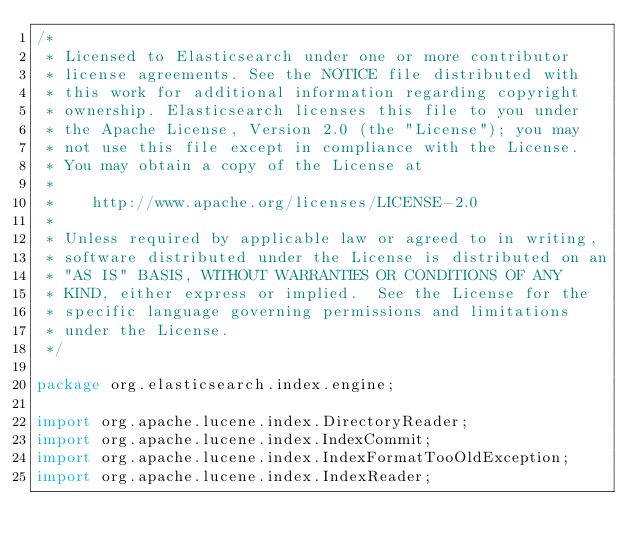<code> <loc_0><loc_0><loc_500><loc_500><_Java_>/*
 * Licensed to Elasticsearch under one or more contributor
 * license agreements. See the NOTICE file distributed with
 * this work for additional information regarding copyright
 * ownership. Elasticsearch licenses this file to you under
 * the Apache License, Version 2.0 (the "License"); you may
 * not use this file except in compliance with the License.
 * You may obtain a copy of the License at
 *
 *    http://www.apache.org/licenses/LICENSE-2.0
 *
 * Unless required by applicable law or agreed to in writing,
 * software distributed under the License is distributed on an
 * "AS IS" BASIS, WITHOUT WARRANTIES OR CONDITIONS OF ANY
 * KIND, either express or implied.  See the License for the
 * specific language governing permissions and limitations
 * under the License.
 */

package org.elasticsearch.index.engine;

import org.apache.lucene.index.DirectoryReader;
import org.apache.lucene.index.IndexCommit;
import org.apache.lucene.index.IndexFormatTooOldException;
import org.apache.lucene.index.IndexReader;</code> 